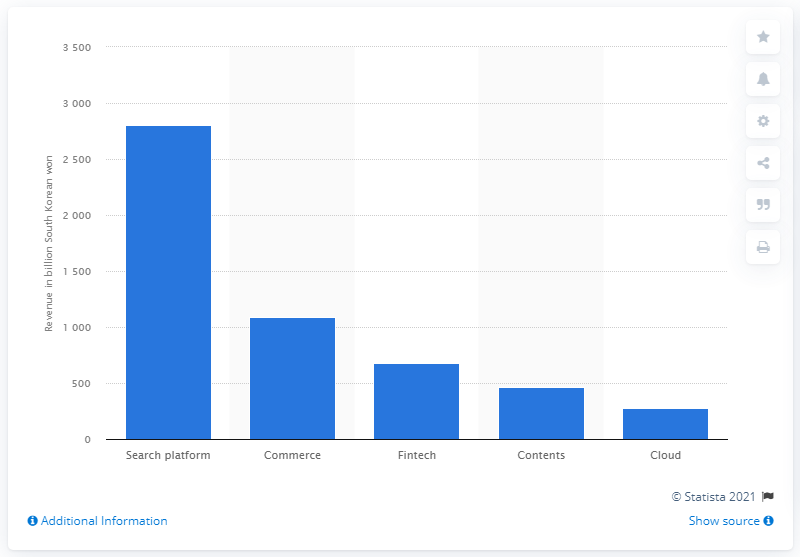Give some essential details in this illustration. Naver's operating revenue from search platforms in South Korea in 2020 was 280.31 billion won. 